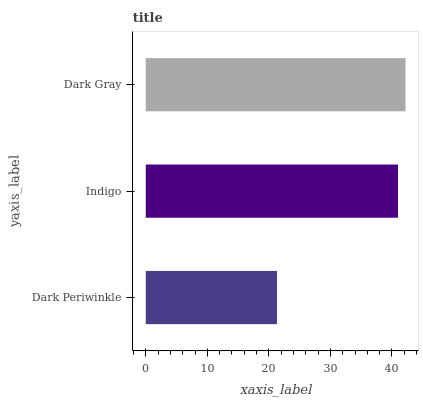Is Dark Periwinkle the minimum?
Answer yes or no. Yes. Is Dark Gray the maximum?
Answer yes or no. Yes. Is Indigo the minimum?
Answer yes or no. No. Is Indigo the maximum?
Answer yes or no. No. Is Indigo greater than Dark Periwinkle?
Answer yes or no. Yes. Is Dark Periwinkle less than Indigo?
Answer yes or no. Yes. Is Dark Periwinkle greater than Indigo?
Answer yes or no. No. Is Indigo less than Dark Periwinkle?
Answer yes or no. No. Is Indigo the high median?
Answer yes or no. Yes. Is Indigo the low median?
Answer yes or no. Yes. Is Dark Gray the high median?
Answer yes or no. No. Is Dark Gray the low median?
Answer yes or no. No. 